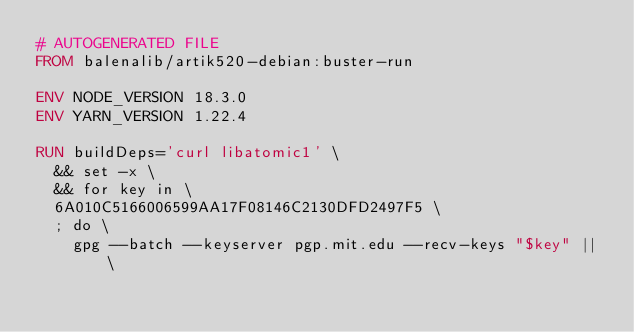Convert code to text. <code><loc_0><loc_0><loc_500><loc_500><_Dockerfile_># AUTOGENERATED FILE
FROM balenalib/artik520-debian:buster-run

ENV NODE_VERSION 18.3.0
ENV YARN_VERSION 1.22.4

RUN buildDeps='curl libatomic1' \
	&& set -x \
	&& for key in \
	6A010C5166006599AA17F08146C2130DFD2497F5 \
	; do \
		gpg --batch --keyserver pgp.mit.edu --recv-keys "$key" || \</code> 